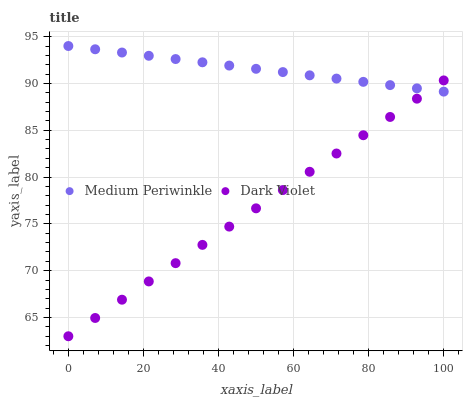Does Dark Violet have the minimum area under the curve?
Answer yes or no. Yes. Does Medium Periwinkle have the maximum area under the curve?
Answer yes or no. Yes. Does Dark Violet have the maximum area under the curve?
Answer yes or no. No. Is Dark Violet the smoothest?
Answer yes or no. Yes. Is Medium Periwinkle the roughest?
Answer yes or no. Yes. Is Dark Violet the roughest?
Answer yes or no. No. Does Dark Violet have the lowest value?
Answer yes or no. Yes. Does Medium Periwinkle have the highest value?
Answer yes or no. Yes. Does Dark Violet have the highest value?
Answer yes or no. No. Does Medium Periwinkle intersect Dark Violet?
Answer yes or no. Yes. Is Medium Periwinkle less than Dark Violet?
Answer yes or no. No. Is Medium Periwinkle greater than Dark Violet?
Answer yes or no. No. 